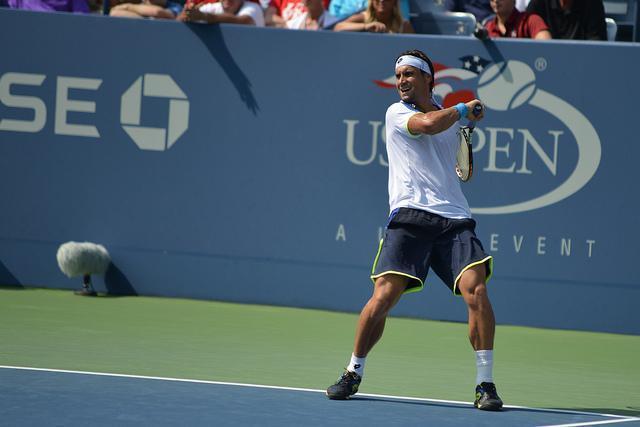Why does he have the racquet behind him?
Answer the question by selecting the correct answer among the 4 following choices.
Options: Strike ball, bad arm, stole it, hiding it. Strike ball. 